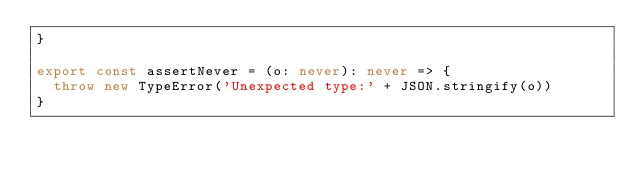<code> <loc_0><loc_0><loc_500><loc_500><_TypeScript_>}

export const assertNever = (o: never): never => {
  throw new TypeError('Unexpected type:' + JSON.stringify(o))
}
</code> 